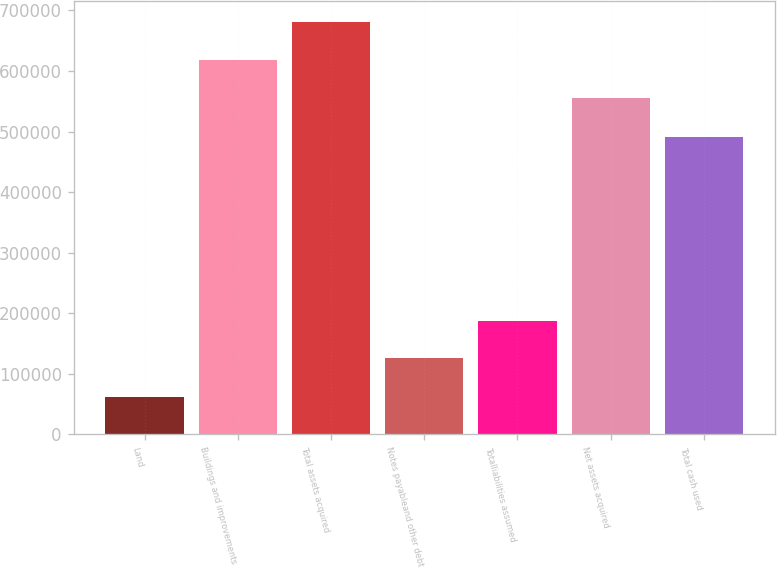Convert chart to OTSL. <chart><loc_0><loc_0><loc_500><loc_500><bar_chart><fcel>Land<fcel>Buildings and improvements<fcel>Total assets acquired<fcel>Notes payableand other debt<fcel>Totalliabilities assumed<fcel>Net assets acquired<fcel>Total cash used<nl><fcel>62436<fcel>617982<fcel>680903<fcel>125633<fcel>187480<fcel>555257<fcel>490257<nl></chart> 